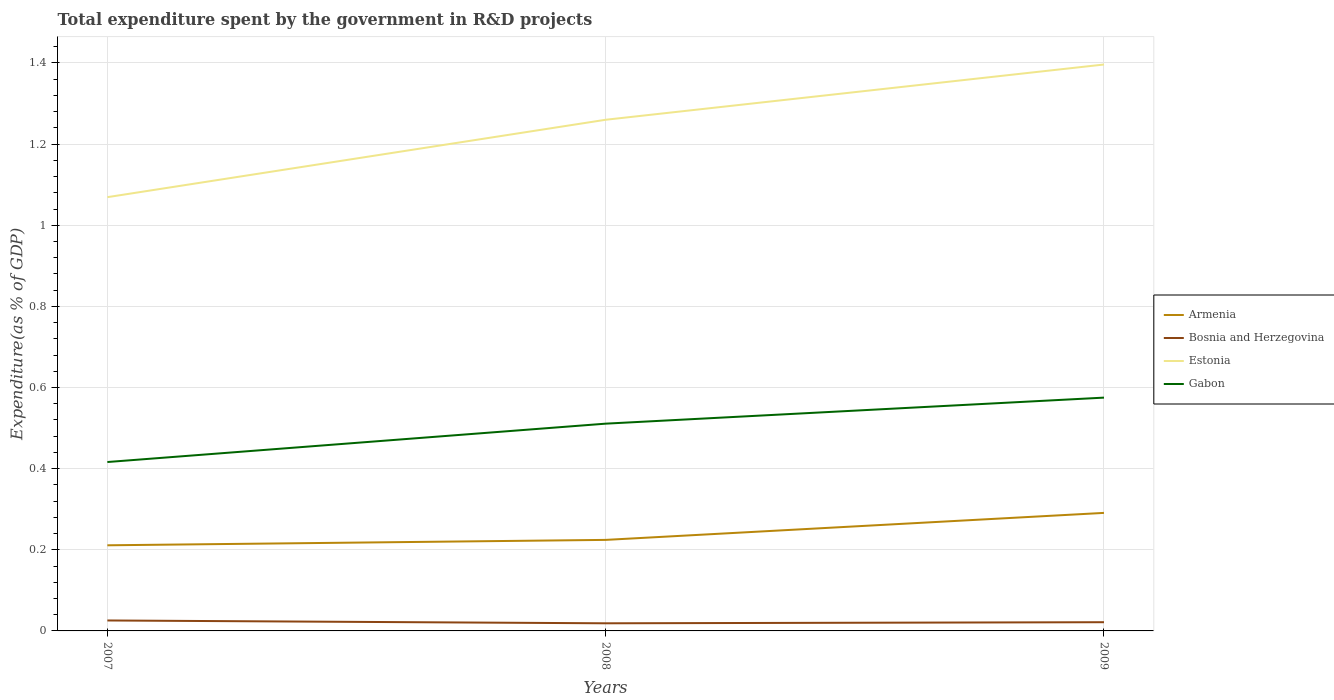Is the number of lines equal to the number of legend labels?
Make the answer very short. Yes. Across all years, what is the maximum total expenditure spent by the government in R&D projects in Estonia?
Make the answer very short. 1.07. What is the total total expenditure spent by the government in R&D projects in Estonia in the graph?
Your answer should be compact. -0.14. What is the difference between the highest and the second highest total expenditure spent by the government in R&D projects in Armenia?
Offer a very short reply. 0.08. Is the total expenditure spent by the government in R&D projects in Armenia strictly greater than the total expenditure spent by the government in R&D projects in Gabon over the years?
Your response must be concise. Yes. How many lines are there?
Provide a succinct answer. 4. How many years are there in the graph?
Make the answer very short. 3. Are the values on the major ticks of Y-axis written in scientific E-notation?
Ensure brevity in your answer.  No. Does the graph contain grids?
Give a very brief answer. Yes. Where does the legend appear in the graph?
Make the answer very short. Center right. How are the legend labels stacked?
Offer a very short reply. Vertical. What is the title of the graph?
Give a very brief answer. Total expenditure spent by the government in R&D projects. Does "South Asia" appear as one of the legend labels in the graph?
Provide a succinct answer. No. What is the label or title of the Y-axis?
Your answer should be very brief. Expenditure(as % of GDP). What is the Expenditure(as % of GDP) of Armenia in 2007?
Provide a succinct answer. 0.21. What is the Expenditure(as % of GDP) of Bosnia and Herzegovina in 2007?
Your response must be concise. 0.03. What is the Expenditure(as % of GDP) in Estonia in 2007?
Your response must be concise. 1.07. What is the Expenditure(as % of GDP) of Gabon in 2007?
Provide a short and direct response. 0.42. What is the Expenditure(as % of GDP) in Armenia in 2008?
Ensure brevity in your answer.  0.22. What is the Expenditure(as % of GDP) of Bosnia and Herzegovina in 2008?
Provide a succinct answer. 0.02. What is the Expenditure(as % of GDP) in Estonia in 2008?
Give a very brief answer. 1.26. What is the Expenditure(as % of GDP) of Gabon in 2008?
Give a very brief answer. 0.51. What is the Expenditure(as % of GDP) of Armenia in 2009?
Your response must be concise. 0.29. What is the Expenditure(as % of GDP) of Bosnia and Herzegovina in 2009?
Provide a short and direct response. 0.02. What is the Expenditure(as % of GDP) in Estonia in 2009?
Offer a very short reply. 1.4. What is the Expenditure(as % of GDP) of Gabon in 2009?
Your answer should be very brief. 0.58. Across all years, what is the maximum Expenditure(as % of GDP) of Armenia?
Your answer should be compact. 0.29. Across all years, what is the maximum Expenditure(as % of GDP) in Bosnia and Herzegovina?
Keep it short and to the point. 0.03. Across all years, what is the maximum Expenditure(as % of GDP) of Estonia?
Give a very brief answer. 1.4. Across all years, what is the maximum Expenditure(as % of GDP) of Gabon?
Your answer should be very brief. 0.58. Across all years, what is the minimum Expenditure(as % of GDP) of Armenia?
Offer a terse response. 0.21. Across all years, what is the minimum Expenditure(as % of GDP) in Bosnia and Herzegovina?
Make the answer very short. 0.02. Across all years, what is the minimum Expenditure(as % of GDP) in Estonia?
Provide a short and direct response. 1.07. Across all years, what is the minimum Expenditure(as % of GDP) in Gabon?
Keep it short and to the point. 0.42. What is the total Expenditure(as % of GDP) of Armenia in the graph?
Your answer should be very brief. 0.73. What is the total Expenditure(as % of GDP) in Bosnia and Herzegovina in the graph?
Offer a very short reply. 0.07. What is the total Expenditure(as % of GDP) in Estonia in the graph?
Offer a terse response. 3.73. What is the total Expenditure(as % of GDP) in Gabon in the graph?
Keep it short and to the point. 1.5. What is the difference between the Expenditure(as % of GDP) of Armenia in 2007 and that in 2008?
Ensure brevity in your answer.  -0.01. What is the difference between the Expenditure(as % of GDP) in Bosnia and Herzegovina in 2007 and that in 2008?
Your response must be concise. 0.01. What is the difference between the Expenditure(as % of GDP) in Estonia in 2007 and that in 2008?
Offer a very short reply. -0.19. What is the difference between the Expenditure(as % of GDP) of Gabon in 2007 and that in 2008?
Your answer should be very brief. -0.09. What is the difference between the Expenditure(as % of GDP) in Armenia in 2007 and that in 2009?
Your answer should be compact. -0.08. What is the difference between the Expenditure(as % of GDP) of Bosnia and Herzegovina in 2007 and that in 2009?
Provide a succinct answer. 0. What is the difference between the Expenditure(as % of GDP) of Estonia in 2007 and that in 2009?
Give a very brief answer. -0.33. What is the difference between the Expenditure(as % of GDP) of Gabon in 2007 and that in 2009?
Your response must be concise. -0.16. What is the difference between the Expenditure(as % of GDP) of Armenia in 2008 and that in 2009?
Your response must be concise. -0.07. What is the difference between the Expenditure(as % of GDP) of Bosnia and Herzegovina in 2008 and that in 2009?
Your answer should be compact. -0. What is the difference between the Expenditure(as % of GDP) in Estonia in 2008 and that in 2009?
Keep it short and to the point. -0.14. What is the difference between the Expenditure(as % of GDP) of Gabon in 2008 and that in 2009?
Give a very brief answer. -0.06. What is the difference between the Expenditure(as % of GDP) in Armenia in 2007 and the Expenditure(as % of GDP) in Bosnia and Herzegovina in 2008?
Provide a succinct answer. 0.19. What is the difference between the Expenditure(as % of GDP) of Armenia in 2007 and the Expenditure(as % of GDP) of Estonia in 2008?
Make the answer very short. -1.05. What is the difference between the Expenditure(as % of GDP) of Armenia in 2007 and the Expenditure(as % of GDP) of Gabon in 2008?
Your answer should be very brief. -0.3. What is the difference between the Expenditure(as % of GDP) of Bosnia and Herzegovina in 2007 and the Expenditure(as % of GDP) of Estonia in 2008?
Your answer should be very brief. -1.23. What is the difference between the Expenditure(as % of GDP) of Bosnia and Herzegovina in 2007 and the Expenditure(as % of GDP) of Gabon in 2008?
Provide a short and direct response. -0.49. What is the difference between the Expenditure(as % of GDP) in Estonia in 2007 and the Expenditure(as % of GDP) in Gabon in 2008?
Your answer should be very brief. 0.56. What is the difference between the Expenditure(as % of GDP) of Armenia in 2007 and the Expenditure(as % of GDP) of Bosnia and Herzegovina in 2009?
Provide a short and direct response. 0.19. What is the difference between the Expenditure(as % of GDP) in Armenia in 2007 and the Expenditure(as % of GDP) in Estonia in 2009?
Keep it short and to the point. -1.19. What is the difference between the Expenditure(as % of GDP) of Armenia in 2007 and the Expenditure(as % of GDP) of Gabon in 2009?
Offer a very short reply. -0.36. What is the difference between the Expenditure(as % of GDP) in Bosnia and Herzegovina in 2007 and the Expenditure(as % of GDP) in Estonia in 2009?
Your response must be concise. -1.37. What is the difference between the Expenditure(as % of GDP) in Bosnia and Herzegovina in 2007 and the Expenditure(as % of GDP) in Gabon in 2009?
Make the answer very short. -0.55. What is the difference between the Expenditure(as % of GDP) of Estonia in 2007 and the Expenditure(as % of GDP) of Gabon in 2009?
Make the answer very short. 0.49. What is the difference between the Expenditure(as % of GDP) in Armenia in 2008 and the Expenditure(as % of GDP) in Bosnia and Herzegovina in 2009?
Make the answer very short. 0.2. What is the difference between the Expenditure(as % of GDP) in Armenia in 2008 and the Expenditure(as % of GDP) in Estonia in 2009?
Offer a very short reply. -1.17. What is the difference between the Expenditure(as % of GDP) of Armenia in 2008 and the Expenditure(as % of GDP) of Gabon in 2009?
Offer a terse response. -0.35. What is the difference between the Expenditure(as % of GDP) in Bosnia and Herzegovina in 2008 and the Expenditure(as % of GDP) in Estonia in 2009?
Ensure brevity in your answer.  -1.38. What is the difference between the Expenditure(as % of GDP) in Bosnia and Herzegovina in 2008 and the Expenditure(as % of GDP) in Gabon in 2009?
Your answer should be very brief. -0.56. What is the difference between the Expenditure(as % of GDP) of Estonia in 2008 and the Expenditure(as % of GDP) of Gabon in 2009?
Provide a succinct answer. 0.68. What is the average Expenditure(as % of GDP) in Armenia per year?
Your answer should be compact. 0.24. What is the average Expenditure(as % of GDP) in Bosnia and Herzegovina per year?
Make the answer very short. 0.02. What is the average Expenditure(as % of GDP) in Estonia per year?
Ensure brevity in your answer.  1.24. What is the average Expenditure(as % of GDP) of Gabon per year?
Give a very brief answer. 0.5. In the year 2007, what is the difference between the Expenditure(as % of GDP) in Armenia and Expenditure(as % of GDP) in Bosnia and Herzegovina?
Keep it short and to the point. 0.19. In the year 2007, what is the difference between the Expenditure(as % of GDP) in Armenia and Expenditure(as % of GDP) in Estonia?
Your answer should be very brief. -0.86. In the year 2007, what is the difference between the Expenditure(as % of GDP) in Armenia and Expenditure(as % of GDP) in Gabon?
Provide a short and direct response. -0.21. In the year 2007, what is the difference between the Expenditure(as % of GDP) of Bosnia and Herzegovina and Expenditure(as % of GDP) of Estonia?
Make the answer very short. -1.04. In the year 2007, what is the difference between the Expenditure(as % of GDP) of Bosnia and Herzegovina and Expenditure(as % of GDP) of Gabon?
Ensure brevity in your answer.  -0.39. In the year 2007, what is the difference between the Expenditure(as % of GDP) of Estonia and Expenditure(as % of GDP) of Gabon?
Keep it short and to the point. 0.65. In the year 2008, what is the difference between the Expenditure(as % of GDP) of Armenia and Expenditure(as % of GDP) of Bosnia and Herzegovina?
Ensure brevity in your answer.  0.21. In the year 2008, what is the difference between the Expenditure(as % of GDP) of Armenia and Expenditure(as % of GDP) of Estonia?
Your answer should be very brief. -1.04. In the year 2008, what is the difference between the Expenditure(as % of GDP) of Armenia and Expenditure(as % of GDP) of Gabon?
Keep it short and to the point. -0.29. In the year 2008, what is the difference between the Expenditure(as % of GDP) in Bosnia and Herzegovina and Expenditure(as % of GDP) in Estonia?
Your answer should be compact. -1.24. In the year 2008, what is the difference between the Expenditure(as % of GDP) in Bosnia and Herzegovina and Expenditure(as % of GDP) in Gabon?
Your answer should be very brief. -0.49. In the year 2008, what is the difference between the Expenditure(as % of GDP) in Estonia and Expenditure(as % of GDP) in Gabon?
Make the answer very short. 0.75. In the year 2009, what is the difference between the Expenditure(as % of GDP) in Armenia and Expenditure(as % of GDP) in Bosnia and Herzegovina?
Your answer should be very brief. 0.27. In the year 2009, what is the difference between the Expenditure(as % of GDP) in Armenia and Expenditure(as % of GDP) in Estonia?
Give a very brief answer. -1.11. In the year 2009, what is the difference between the Expenditure(as % of GDP) in Armenia and Expenditure(as % of GDP) in Gabon?
Offer a very short reply. -0.28. In the year 2009, what is the difference between the Expenditure(as % of GDP) in Bosnia and Herzegovina and Expenditure(as % of GDP) in Estonia?
Make the answer very short. -1.37. In the year 2009, what is the difference between the Expenditure(as % of GDP) in Bosnia and Herzegovina and Expenditure(as % of GDP) in Gabon?
Make the answer very short. -0.55. In the year 2009, what is the difference between the Expenditure(as % of GDP) in Estonia and Expenditure(as % of GDP) in Gabon?
Your response must be concise. 0.82. What is the ratio of the Expenditure(as % of GDP) of Armenia in 2007 to that in 2008?
Offer a terse response. 0.94. What is the ratio of the Expenditure(as % of GDP) of Bosnia and Herzegovina in 2007 to that in 2008?
Provide a succinct answer. 1.37. What is the ratio of the Expenditure(as % of GDP) of Estonia in 2007 to that in 2008?
Provide a succinct answer. 0.85. What is the ratio of the Expenditure(as % of GDP) of Gabon in 2007 to that in 2008?
Your answer should be very brief. 0.81. What is the ratio of the Expenditure(as % of GDP) of Armenia in 2007 to that in 2009?
Offer a terse response. 0.73. What is the ratio of the Expenditure(as % of GDP) in Bosnia and Herzegovina in 2007 to that in 2009?
Your answer should be very brief. 1.2. What is the ratio of the Expenditure(as % of GDP) in Estonia in 2007 to that in 2009?
Your response must be concise. 0.77. What is the ratio of the Expenditure(as % of GDP) of Gabon in 2007 to that in 2009?
Your response must be concise. 0.72. What is the ratio of the Expenditure(as % of GDP) of Armenia in 2008 to that in 2009?
Give a very brief answer. 0.77. What is the ratio of the Expenditure(as % of GDP) in Bosnia and Herzegovina in 2008 to that in 2009?
Ensure brevity in your answer.  0.88. What is the ratio of the Expenditure(as % of GDP) of Estonia in 2008 to that in 2009?
Keep it short and to the point. 0.9. What is the ratio of the Expenditure(as % of GDP) of Gabon in 2008 to that in 2009?
Provide a succinct answer. 0.89. What is the difference between the highest and the second highest Expenditure(as % of GDP) in Armenia?
Provide a succinct answer. 0.07. What is the difference between the highest and the second highest Expenditure(as % of GDP) in Bosnia and Herzegovina?
Your answer should be compact. 0. What is the difference between the highest and the second highest Expenditure(as % of GDP) in Estonia?
Give a very brief answer. 0.14. What is the difference between the highest and the second highest Expenditure(as % of GDP) of Gabon?
Your answer should be very brief. 0.06. What is the difference between the highest and the lowest Expenditure(as % of GDP) in Armenia?
Your answer should be compact. 0.08. What is the difference between the highest and the lowest Expenditure(as % of GDP) in Bosnia and Herzegovina?
Make the answer very short. 0.01. What is the difference between the highest and the lowest Expenditure(as % of GDP) in Estonia?
Keep it short and to the point. 0.33. What is the difference between the highest and the lowest Expenditure(as % of GDP) in Gabon?
Make the answer very short. 0.16. 